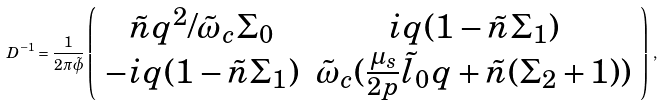Convert formula to latex. <formula><loc_0><loc_0><loc_500><loc_500>D ^ { - 1 } = \frac { 1 } { 2 \pi \tilde { \phi } } \left ( \begin{array} { c c } \tilde { n } q ^ { 2 } / \tilde { \omega } _ { c } \Sigma _ { 0 } & i q ( 1 - \tilde { n } \Sigma _ { 1 } ) \\ - i q ( 1 - \tilde { n } \Sigma _ { 1 } ) & \tilde { \omega } _ { c } ( \frac { \mu _ { s } } { 2 p } \tilde { l } _ { 0 } q + \tilde { n } ( \Sigma _ { 2 } + 1 ) ) \end{array} \right ) \, ,</formula> 